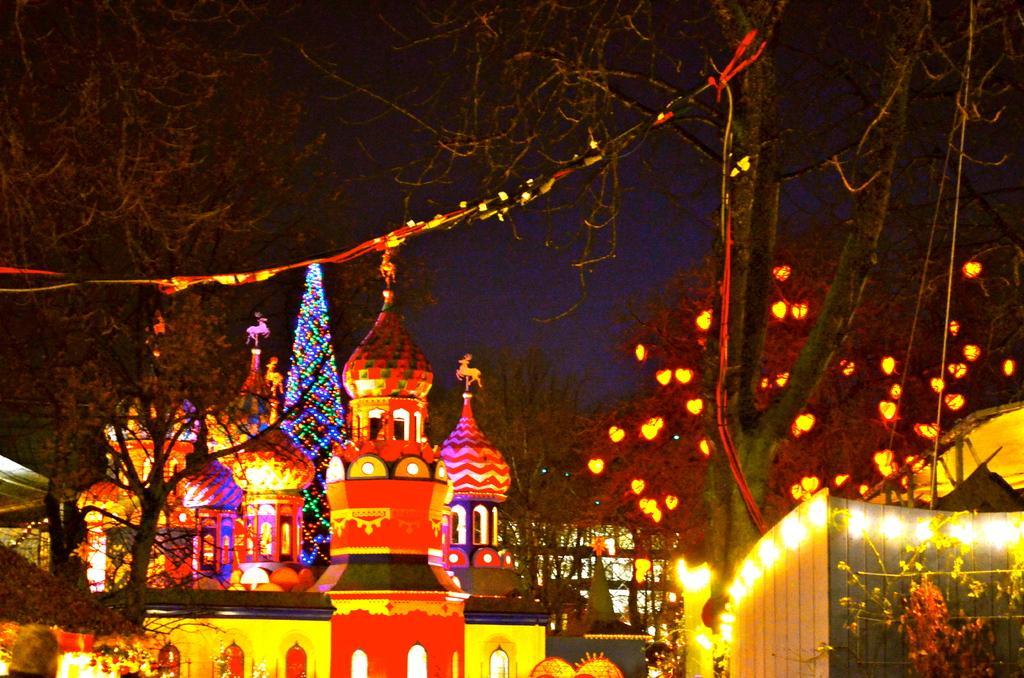Could you give a brief overview of what you see in this image? In this image at the bottom, there are buildings, decorations, lights, trees, plants. At the top there are trees, lightnings, sky. 